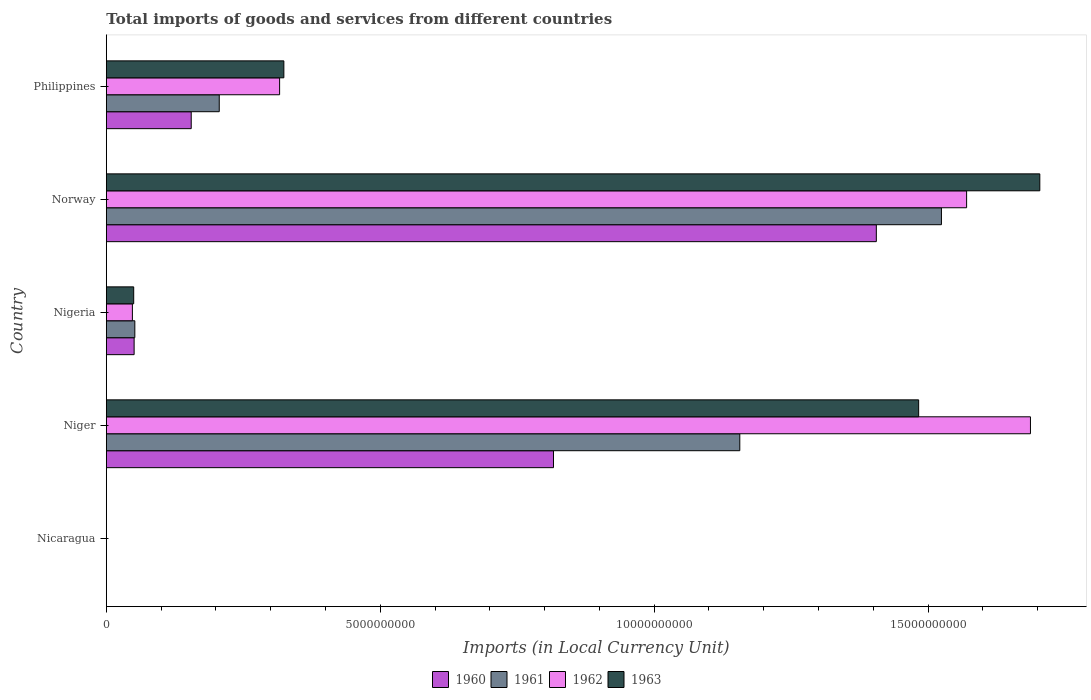How many different coloured bars are there?
Ensure brevity in your answer.  4. How many groups of bars are there?
Your answer should be very brief. 5. Are the number of bars per tick equal to the number of legend labels?
Offer a very short reply. Yes. How many bars are there on the 5th tick from the bottom?
Make the answer very short. 4. What is the label of the 5th group of bars from the top?
Keep it short and to the point. Nicaragua. In how many cases, is the number of bars for a given country not equal to the number of legend labels?
Offer a terse response. 0. What is the Amount of goods and services imports in 1963 in Nigeria?
Offer a terse response. 4.99e+08. Across all countries, what is the maximum Amount of goods and services imports in 1962?
Keep it short and to the point. 1.69e+1. Across all countries, what is the minimum Amount of goods and services imports in 1962?
Your answer should be very brief. 0.16. In which country was the Amount of goods and services imports in 1963 maximum?
Your response must be concise. Norway. In which country was the Amount of goods and services imports in 1960 minimum?
Give a very brief answer. Nicaragua. What is the total Amount of goods and services imports in 1960 in the graph?
Your answer should be compact. 2.43e+1. What is the difference between the Amount of goods and services imports in 1960 in Niger and that in Nigeria?
Ensure brevity in your answer.  7.66e+09. What is the difference between the Amount of goods and services imports in 1963 in Philippines and the Amount of goods and services imports in 1961 in Norway?
Offer a terse response. -1.20e+1. What is the average Amount of goods and services imports in 1960 per country?
Your answer should be compact. 4.85e+09. What is the difference between the Amount of goods and services imports in 1962 and Amount of goods and services imports in 1963 in Nicaragua?
Keep it short and to the point. -0.03. In how many countries, is the Amount of goods and services imports in 1963 greater than 8000000000 LCU?
Your answer should be very brief. 2. What is the ratio of the Amount of goods and services imports in 1962 in Nicaragua to that in Niger?
Provide a short and direct response. 9.54576297213908e-12. What is the difference between the highest and the second highest Amount of goods and services imports in 1963?
Keep it short and to the point. 2.21e+09. What is the difference between the highest and the lowest Amount of goods and services imports in 1963?
Keep it short and to the point. 1.70e+1. In how many countries, is the Amount of goods and services imports in 1963 greater than the average Amount of goods and services imports in 1963 taken over all countries?
Make the answer very short. 2. What does the 2nd bar from the bottom in Niger represents?
Provide a short and direct response. 1961. Are all the bars in the graph horizontal?
Keep it short and to the point. Yes. What is the difference between two consecutive major ticks on the X-axis?
Make the answer very short. 5.00e+09. Are the values on the major ticks of X-axis written in scientific E-notation?
Your answer should be compact. No. Does the graph contain any zero values?
Your response must be concise. No. Where does the legend appear in the graph?
Provide a short and direct response. Bottom center. How many legend labels are there?
Offer a very short reply. 4. How are the legend labels stacked?
Provide a short and direct response. Horizontal. What is the title of the graph?
Provide a short and direct response. Total imports of goods and services from different countries. What is the label or title of the X-axis?
Provide a short and direct response. Imports (in Local Currency Unit). What is the Imports (in Local Currency Unit) of 1960 in Nicaragua?
Offer a terse response. 0.12. What is the Imports (in Local Currency Unit) in 1961 in Nicaragua?
Give a very brief answer. 0.12. What is the Imports (in Local Currency Unit) of 1962 in Nicaragua?
Offer a very short reply. 0.16. What is the Imports (in Local Currency Unit) in 1963 in Nicaragua?
Give a very brief answer. 0.19. What is the Imports (in Local Currency Unit) of 1960 in Niger?
Your answer should be compact. 8.16e+09. What is the Imports (in Local Currency Unit) in 1961 in Niger?
Provide a succinct answer. 1.16e+1. What is the Imports (in Local Currency Unit) of 1962 in Niger?
Provide a succinct answer. 1.69e+1. What is the Imports (in Local Currency Unit) in 1963 in Niger?
Offer a terse response. 1.48e+1. What is the Imports (in Local Currency Unit) of 1960 in Nigeria?
Ensure brevity in your answer.  5.07e+08. What is the Imports (in Local Currency Unit) of 1961 in Nigeria?
Ensure brevity in your answer.  5.20e+08. What is the Imports (in Local Currency Unit) in 1962 in Nigeria?
Offer a very short reply. 4.76e+08. What is the Imports (in Local Currency Unit) of 1963 in Nigeria?
Provide a succinct answer. 4.99e+08. What is the Imports (in Local Currency Unit) of 1960 in Norway?
Offer a very short reply. 1.41e+1. What is the Imports (in Local Currency Unit) of 1961 in Norway?
Keep it short and to the point. 1.52e+1. What is the Imports (in Local Currency Unit) in 1962 in Norway?
Keep it short and to the point. 1.57e+1. What is the Imports (in Local Currency Unit) in 1963 in Norway?
Provide a succinct answer. 1.70e+1. What is the Imports (in Local Currency Unit) of 1960 in Philippines?
Ensure brevity in your answer.  1.55e+09. What is the Imports (in Local Currency Unit) in 1961 in Philippines?
Ensure brevity in your answer.  2.06e+09. What is the Imports (in Local Currency Unit) in 1962 in Philippines?
Give a very brief answer. 3.16e+09. What is the Imports (in Local Currency Unit) in 1963 in Philippines?
Provide a short and direct response. 3.24e+09. Across all countries, what is the maximum Imports (in Local Currency Unit) of 1960?
Your answer should be compact. 1.41e+1. Across all countries, what is the maximum Imports (in Local Currency Unit) of 1961?
Your answer should be compact. 1.52e+1. Across all countries, what is the maximum Imports (in Local Currency Unit) of 1962?
Give a very brief answer. 1.69e+1. Across all countries, what is the maximum Imports (in Local Currency Unit) in 1963?
Offer a terse response. 1.70e+1. Across all countries, what is the minimum Imports (in Local Currency Unit) in 1960?
Ensure brevity in your answer.  0.12. Across all countries, what is the minimum Imports (in Local Currency Unit) of 1961?
Offer a terse response. 0.12. Across all countries, what is the minimum Imports (in Local Currency Unit) of 1962?
Your answer should be very brief. 0.16. Across all countries, what is the minimum Imports (in Local Currency Unit) in 1963?
Your answer should be very brief. 0.19. What is the total Imports (in Local Currency Unit) of 1960 in the graph?
Offer a very short reply. 2.43e+1. What is the total Imports (in Local Currency Unit) in 1961 in the graph?
Your answer should be compact. 2.94e+1. What is the total Imports (in Local Currency Unit) of 1962 in the graph?
Offer a very short reply. 3.62e+1. What is the total Imports (in Local Currency Unit) of 1963 in the graph?
Offer a very short reply. 3.56e+1. What is the difference between the Imports (in Local Currency Unit) of 1960 in Nicaragua and that in Niger?
Offer a very short reply. -8.16e+09. What is the difference between the Imports (in Local Currency Unit) of 1961 in Nicaragua and that in Niger?
Your answer should be very brief. -1.16e+1. What is the difference between the Imports (in Local Currency Unit) of 1962 in Nicaragua and that in Niger?
Your answer should be compact. -1.69e+1. What is the difference between the Imports (in Local Currency Unit) in 1963 in Nicaragua and that in Niger?
Ensure brevity in your answer.  -1.48e+1. What is the difference between the Imports (in Local Currency Unit) in 1960 in Nicaragua and that in Nigeria?
Offer a terse response. -5.07e+08. What is the difference between the Imports (in Local Currency Unit) of 1961 in Nicaragua and that in Nigeria?
Your answer should be very brief. -5.20e+08. What is the difference between the Imports (in Local Currency Unit) of 1962 in Nicaragua and that in Nigeria?
Give a very brief answer. -4.76e+08. What is the difference between the Imports (in Local Currency Unit) in 1963 in Nicaragua and that in Nigeria?
Your answer should be compact. -4.99e+08. What is the difference between the Imports (in Local Currency Unit) of 1960 in Nicaragua and that in Norway?
Your response must be concise. -1.41e+1. What is the difference between the Imports (in Local Currency Unit) in 1961 in Nicaragua and that in Norway?
Your response must be concise. -1.52e+1. What is the difference between the Imports (in Local Currency Unit) of 1962 in Nicaragua and that in Norway?
Your answer should be very brief. -1.57e+1. What is the difference between the Imports (in Local Currency Unit) of 1963 in Nicaragua and that in Norway?
Keep it short and to the point. -1.70e+1. What is the difference between the Imports (in Local Currency Unit) of 1960 in Nicaragua and that in Philippines?
Your answer should be compact. -1.55e+09. What is the difference between the Imports (in Local Currency Unit) in 1961 in Nicaragua and that in Philippines?
Give a very brief answer. -2.06e+09. What is the difference between the Imports (in Local Currency Unit) of 1962 in Nicaragua and that in Philippines?
Provide a short and direct response. -3.16e+09. What is the difference between the Imports (in Local Currency Unit) in 1963 in Nicaragua and that in Philippines?
Keep it short and to the point. -3.24e+09. What is the difference between the Imports (in Local Currency Unit) of 1960 in Niger and that in Nigeria?
Give a very brief answer. 7.66e+09. What is the difference between the Imports (in Local Currency Unit) of 1961 in Niger and that in Nigeria?
Provide a short and direct response. 1.10e+1. What is the difference between the Imports (in Local Currency Unit) in 1962 in Niger and that in Nigeria?
Offer a very short reply. 1.64e+1. What is the difference between the Imports (in Local Currency Unit) in 1963 in Niger and that in Nigeria?
Ensure brevity in your answer.  1.43e+1. What is the difference between the Imports (in Local Currency Unit) of 1960 in Niger and that in Norway?
Offer a terse response. -5.89e+09. What is the difference between the Imports (in Local Currency Unit) in 1961 in Niger and that in Norway?
Ensure brevity in your answer.  -3.68e+09. What is the difference between the Imports (in Local Currency Unit) in 1962 in Niger and that in Norway?
Offer a terse response. 1.17e+09. What is the difference between the Imports (in Local Currency Unit) in 1963 in Niger and that in Norway?
Offer a very short reply. -2.21e+09. What is the difference between the Imports (in Local Currency Unit) in 1960 in Niger and that in Philippines?
Ensure brevity in your answer.  6.61e+09. What is the difference between the Imports (in Local Currency Unit) of 1961 in Niger and that in Philippines?
Provide a short and direct response. 9.50e+09. What is the difference between the Imports (in Local Currency Unit) of 1962 in Niger and that in Philippines?
Offer a very short reply. 1.37e+1. What is the difference between the Imports (in Local Currency Unit) in 1963 in Niger and that in Philippines?
Keep it short and to the point. 1.16e+1. What is the difference between the Imports (in Local Currency Unit) in 1960 in Nigeria and that in Norway?
Your answer should be very brief. -1.35e+1. What is the difference between the Imports (in Local Currency Unit) in 1961 in Nigeria and that in Norway?
Your answer should be very brief. -1.47e+1. What is the difference between the Imports (in Local Currency Unit) in 1962 in Nigeria and that in Norway?
Your answer should be compact. -1.52e+1. What is the difference between the Imports (in Local Currency Unit) in 1963 in Nigeria and that in Norway?
Provide a short and direct response. -1.65e+1. What is the difference between the Imports (in Local Currency Unit) of 1960 in Nigeria and that in Philippines?
Provide a short and direct response. -1.04e+09. What is the difference between the Imports (in Local Currency Unit) of 1961 in Nigeria and that in Philippines?
Your answer should be compact. -1.54e+09. What is the difference between the Imports (in Local Currency Unit) in 1962 in Nigeria and that in Philippines?
Give a very brief answer. -2.69e+09. What is the difference between the Imports (in Local Currency Unit) of 1963 in Nigeria and that in Philippines?
Your response must be concise. -2.74e+09. What is the difference between the Imports (in Local Currency Unit) in 1960 in Norway and that in Philippines?
Your answer should be compact. 1.25e+1. What is the difference between the Imports (in Local Currency Unit) of 1961 in Norway and that in Philippines?
Offer a terse response. 1.32e+1. What is the difference between the Imports (in Local Currency Unit) in 1962 in Norway and that in Philippines?
Give a very brief answer. 1.25e+1. What is the difference between the Imports (in Local Currency Unit) of 1963 in Norway and that in Philippines?
Provide a short and direct response. 1.38e+1. What is the difference between the Imports (in Local Currency Unit) in 1960 in Nicaragua and the Imports (in Local Currency Unit) in 1961 in Niger?
Give a very brief answer. -1.16e+1. What is the difference between the Imports (in Local Currency Unit) of 1960 in Nicaragua and the Imports (in Local Currency Unit) of 1962 in Niger?
Make the answer very short. -1.69e+1. What is the difference between the Imports (in Local Currency Unit) of 1960 in Nicaragua and the Imports (in Local Currency Unit) of 1963 in Niger?
Your response must be concise. -1.48e+1. What is the difference between the Imports (in Local Currency Unit) of 1961 in Nicaragua and the Imports (in Local Currency Unit) of 1962 in Niger?
Make the answer very short. -1.69e+1. What is the difference between the Imports (in Local Currency Unit) of 1961 in Nicaragua and the Imports (in Local Currency Unit) of 1963 in Niger?
Give a very brief answer. -1.48e+1. What is the difference between the Imports (in Local Currency Unit) in 1962 in Nicaragua and the Imports (in Local Currency Unit) in 1963 in Niger?
Make the answer very short. -1.48e+1. What is the difference between the Imports (in Local Currency Unit) of 1960 in Nicaragua and the Imports (in Local Currency Unit) of 1961 in Nigeria?
Ensure brevity in your answer.  -5.20e+08. What is the difference between the Imports (in Local Currency Unit) of 1960 in Nicaragua and the Imports (in Local Currency Unit) of 1962 in Nigeria?
Ensure brevity in your answer.  -4.76e+08. What is the difference between the Imports (in Local Currency Unit) in 1960 in Nicaragua and the Imports (in Local Currency Unit) in 1963 in Nigeria?
Your answer should be compact. -4.99e+08. What is the difference between the Imports (in Local Currency Unit) in 1961 in Nicaragua and the Imports (in Local Currency Unit) in 1962 in Nigeria?
Offer a terse response. -4.76e+08. What is the difference between the Imports (in Local Currency Unit) of 1961 in Nicaragua and the Imports (in Local Currency Unit) of 1963 in Nigeria?
Your answer should be very brief. -4.99e+08. What is the difference between the Imports (in Local Currency Unit) in 1962 in Nicaragua and the Imports (in Local Currency Unit) in 1963 in Nigeria?
Offer a very short reply. -4.99e+08. What is the difference between the Imports (in Local Currency Unit) in 1960 in Nicaragua and the Imports (in Local Currency Unit) in 1961 in Norway?
Ensure brevity in your answer.  -1.52e+1. What is the difference between the Imports (in Local Currency Unit) of 1960 in Nicaragua and the Imports (in Local Currency Unit) of 1962 in Norway?
Ensure brevity in your answer.  -1.57e+1. What is the difference between the Imports (in Local Currency Unit) in 1960 in Nicaragua and the Imports (in Local Currency Unit) in 1963 in Norway?
Give a very brief answer. -1.70e+1. What is the difference between the Imports (in Local Currency Unit) in 1961 in Nicaragua and the Imports (in Local Currency Unit) in 1962 in Norway?
Ensure brevity in your answer.  -1.57e+1. What is the difference between the Imports (in Local Currency Unit) of 1961 in Nicaragua and the Imports (in Local Currency Unit) of 1963 in Norway?
Give a very brief answer. -1.70e+1. What is the difference between the Imports (in Local Currency Unit) in 1962 in Nicaragua and the Imports (in Local Currency Unit) in 1963 in Norway?
Give a very brief answer. -1.70e+1. What is the difference between the Imports (in Local Currency Unit) of 1960 in Nicaragua and the Imports (in Local Currency Unit) of 1961 in Philippines?
Your answer should be very brief. -2.06e+09. What is the difference between the Imports (in Local Currency Unit) in 1960 in Nicaragua and the Imports (in Local Currency Unit) in 1962 in Philippines?
Your answer should be very brief. -3.16e+09. What is the difference between the Imports (in Local Currency Unit) of 1960 in Nicaragua and the Imports (in Local Currency Unit) of 1963 in Philippines?
Provide a short and direct response. -3.24e+09. What is the difference between the Imports (in Local Currency Unit) in 1961 in Nicaragua and the Imports (in Local Currency Unit) in 1962 in Philippines?
Ensure brevity in your answer.  -3.16e+09. What is the difference between the Imports (in Local Currency Unit) in 1961 in Nicaragua and the Imports (in Local Currency Unit) in 1963 in Philippines?
Your answer should be very brief. -3.24e+09. What is the difference between the Imports (in Local Currency Unit) of 1962 in Nicaragua and the Imports (in Local Currency Unit) of 1963 in Philippines?
Your answer should be very brief. -3.24e+09. What is the difference between the Imports (in Local Currency Unit) in 1960 in Niger and the Imports (in Local Currency Unit) in 1961 in Nigeria?
Provide a succinct answer. 7.64e+09. What is the difference between the Imports (in Local Currency Unit) in 1960 in Niger and the Imports (in Local Currency Unit) in 1962 in Nigeria?
Provide a short and direct response. 7.69e+09. What is the difference between the Imports (in Local Currency Unit) of 1960 in Niger and the Imports (in Local Currency Unit) of 1963 in Nigeria?
Your response must be concise. 7.66e+09. What is the difference between the Imports (in Local Currency Unit) of 1961 in Niger and the Imports (in Local Currency Unit) of 1962 in Nigeria?
Ensure brevity in your answer.  1.11e+1. What is the difference between the Imports (in Local Currency Unit) of 1961 in Niger and the Imports (in Local Currency Unit) of 1963 in Nigeria?
Keep it short and to the point. 1.11e+1. What is the difference between the Imports (in Local Currency Unit) of 1962 in Niger and the Imports (in Local Currency Unit) of 1963 in Nigeria?
Make the answer very short. 1.64e+1. What is the difference between the Imports (in Local Currency Unit) of 1960 in Niger and the Imports (in Local Currency Unit) of 1961 in Norway?
Make the answer very short. -7.08e+09. What is the difference between the Imports (in Local Currency Unit) in 1960 in Niger and the Imports (in Local Currency Unit) in 1962 in Norway?
Ensure brevity in your answer.  -7.54e+09. What is the difference between the Imports (in Local Currency Unit) in 1960 in Niger and the Imports (in Local Currency Unit) in 1963 in Norway?
Offer a very short reply. -8.88e+09. What is the difference between the Imports (in Local Currency Unit) in 1961 in Niger and the Imports (in Local Currency Unit) in 1962 in Norway?
Make the answer very short. -4.14e+09. What is the difference between the Imports (in Local Currency Unit) of 1961 in Niger and the Imports (in Local Currency Unit) of 1963 in Norway?
Keep it short and to the point. -5.48e+09. What is the difference between the Imports (in Local Currency Unit) in 1962 in Niger and the Imports (in Local Currency Unit) in 1963 in Norway?
Provide a short and direct response. -1.71e+08. What is the difference between the Imports (in Local Currency Unit) of 1960 in Niger and the Imports (in Local Currency Unit) of 1961 in Philippines?
Ensure brevity in your answer.  6.10e+09. What is the difference between the Imports (in Local Currency Unit) in 1960 in Niger and the Imports (in Local Currency Unit) in 1962 in Philippines?
Offer a very short reply. 5.00e+09. What is the difference between the Imports (in Local Currency Unit) in 1960 in Niger and the Imports (in Local Currency Unit) in 1963 in Philippines?
Provide a succinct answer. 4.92e+09. What is the difference between the Imports (in Local Currency Unit) of 1961 in Niger and the Imports (in Local Currency Unit) of 1962 in Philippines?
Offer a terse response. 8.40e+09. What is the difference between the Imports (in Local Currency Unit) in 1961 in Niger and the Imports (in Local Currency Unit) in 1963 in Philippines?
Your answer should be very brief. 8.32e+09. What is the difference between the Imports (in Local Currency Unit) of 1962 in Niger and the Imports (in Local Currency Unit) of 1963 in Philippines?
Offer a terse response. 1.36e+1. What is the difference between the Imports (in Local Currency Unit) in 1960 in Nigeria and the Imports (in Local Currency Unit) in 1961 in Norway?
Offer a very short reply. -1.47e+1. What is the difference between the Imports (in Local Currency Unit) in 1960 in Nigeria and the Imports (in Local Currency Unit) in 1962 in Norway?
Provide a succinct answer. -1.52e+1. What is the difference between the Imports (in Local Currency Unit) in 1960 in Nigeria and the Imports (in Local Currency Unit) in 1963 in Norway?
Your response must be concise. -1.65e+1. What is the difference between the Imports (in Local Currency Unit) of 1961 in Nigeria and the Imports (in Local Currency Unit) of 1962 in Norway?
Your response must be concise. -1.52e+1. What is the difference between the Imports (in Local Currency Unit) in 1961 in Nigeria and the Imports (in Local Currency Unit) in 1963 in Norway?
Give a very brief answer. -1.65e+1. What is the difference between the Imports (in Local Currency Unit) of 1962 in Nigeria and the Imports (in Local Currency Unit) of 1963 in Norway?
Your answer should be very brief. -1.66e+1. What is the difference between the Imports (in Local Currency Unit) in 1960 in Nigeria and the Imports (in Local Currency Unit) in 1961 in Philippines?
Provide a succinct answer. -1.55e+09. What is the difference between the Imports (in Local Currency Unit) of 1960 in Nigeria and the Imports (in Local Currency Unit) of 1962 in Philippines?
Offer a terse response. -2.66e+09. What is the difference between the Imports (in Local Currency Unit) of 1960 in Nigeria and the Imports (in Local Currency Unit) of 1963 in Philippines?
Provide a succinct answer. -2.73e+09. What is the difference between the Imports (in Local Currency Unit) in 1961 in Nigeria and the Imports (in Local Currency Unit) in 1962 in Philippines?
Ensure brevity in your answer.  -2.64e+09. What is the difference between the Imports (in Local Currency Unit) of 1961 in Nigeria and the Imports (in Local Currency Unit) of 1963 in Philippines?
Keep it short and to the point. -2.72e+09. What is the difference between the Imports (in Local Currency Unit) of 1962 in Nigeria and the Imports (in Local Currency Unit) of 1963 in Philippines?
Provide a short and direct response. -2.76e+09. What is the difference between the Imports (in Local Currency Unit) of 1960 in Norway and the Imports (in Local Currency Unit) of 1961 in Philippines?
Offer a terse response. 1.20e+1. What is the difference between the Imports (in Local Currency Unit) in 1960 in Norway and the Imports (in Local Currency Unit) in 1962 in Philippines?
Your answer should be compact. 1.09e+1. What is the difference between the Imports (in Local Currency Unit) of 1960 in Norway and the Imports (in Local Currency Unit) of 1963 in Philippines?
Your response must be concise. 1.08e+1. What is the difference between the Imports (in Local Currency Unit) of 1961 in Norway and the Imports (in Local Currency Unit) of 1962 in Philippines?
Offer a very short reply. 1.21e+1. What is the difference between the Imports (in Local Currency Unit) in 1961 in Norway and the Imports (in Local Currency Unit) in 1963 in Philippines?
Your answer should be compact. 1.20e+1. What is the difference between the Imports (in Local Currency Unit) of 1962 in Norway and the Imports (in Local Currency Unit) of 1963 in Philippines?
Ensure brevity in your answer.  1.25e+1. What is the average Imports (in Local Currency Unit) in 1960 per country?
Your response must be concise. 4.85e+09. What is the average Imports (in Local Currency Unit) in 1961 per country?
Provide a succinct answer. 5.88e+09. What is the average Imports (in Local Currency Unit) in 1962 per country?
Offer a very short reply. 7.24e+09. What is the average Imports (in Local Currency Unit) of 1963 per country?
Offer a very short reply. 7.12e+09. What is the difference between the Imports (in Local Currency Unit) in 1960 and Imports (in Local Currency Unit) in 1961 in Nicaragua?
Keep it short and to the point. -0. What is the difference between the Imports (in Local Currency Unit) in 1960 and Imports (in Local Currency Unit) in 1962 in Nicaragua?
Provide a succinct answer. -0.04. What is the difference between the Imports (in Local Currency Unit) in 1960 and Imports (in Local Currency Unit) in 1963 in Nicaragua?
Your response must be concise. -0.06. What is the difference between the Imports (in Local Currency Unit) of 1961 and Imports (in Local Currency Unit) of 1962 in Nicaragua?
Your answer should be compact. -0.04. What is the difference between the Imports (in Local Currency Unit) in 1961 and Imports (in Local Currency Unit) in 1963 in Nicaragua?
Offer a terse response. -0.06. What is the difference between the Imports (in Local Currency Unit) in 1962 and Imports (in Local Currency Unit) in 1963 in Nicaragua?
Your response must be concise. -0.03. What is the difference between the Imports (in Local Currency Unit) in 1960 and Imports (in Local Currency Unit) in 1961 in Niger?
Provide a succinct answer. -3.40e+09. What is the difference between the Imports (in Local Currency Unit) in 1960 and Imports (in Local Currency Unit) in 1962 in Niger?
Provide a short and direct response. -8.71e+09. What is the difference between the Imports (in Local Currency Unit) in 1960 and Imports (in Local Currency Unit) in 1963 in Niger?
Make the answer very short. -6.67e+09. What is the difference between the Imports (in Local Currency Unit) in 1961 and Imports (in Local Currency Unit) in 1962 in Niger?
Make the answer very short. -5.31e+09. What is the difference between the Imports (in Local Currency Unit) in 1961 and Imports (in Local Currency Unit) in 1963 in Niger?
Give a very brief answer. -3.26e+09. What is the difference between the Imports (in Local Currency Unit) of 1962 and Imports (in Local Currency Unit) of 1963 in Niger?
Your answer should be compact. 2.04e+09. What is the difference between the Imports (in Local Currency Unit) in 1960 and Imports (in Local Currency Unit) in 1961 in Nigeria?
Provide a short and direct response. -1.28e+07. What is the difference between the Imports (in Local Currency Unit) in 1960 and Imports (in Local Currency Unit) in 1962 in Nigeria?
Provide a succinct answer. 3.18e+07. What is the difference between the Imports (in Local Currency Unit) in 1960 and Imports (in Local Currency Unit) in 1963 in Nigeria?
Your answer should be compact. 7.80e+06. What is the difference between the Imports (in Local Currency Unit) of 1961 and Imports (in Local Currency Unit) of 1962 in Nigeria?
Make the answer very short. 4.46e+07. What is the difference between the Imports (in Local Currency Unit) of 1961 and Imports (in Local Currency Unit) of 1963 in Nigeria?
Your response must be concise. 2.06e+07. What is the difference between the Imports (in Local Currency Unit) of 1962 and Imports (in Local Currency Unit) of 1963 in Nigeria?
Provide a short and direct response. -2.40e+07. What is the difference between the Imports (in Local Currency Unit) of 1960 and Imports (in Local Currency Unit) of 1961 in Norway?
Offer a very short reply. -1.19e+09. What is the difference between the Imports (in Local Currency Unit) in 1960 and Imports (in Local Currency Unit) in 1962 in Norway?
Your response must be concise. -1.65e+09. What is the difference between the Imports (in Local Currency Unit) in 1960 and Imports (in Local Currency Unit) in 1963 in Norway?
Your answer should be very brief. -2.98e+09. What is the difference between the Imports (in Local Currency Unit) of 1961 and Imports (in Local Currency Unit) of 1962 in Norway?
Provide a succinct answer. -4.60e+08. What is the difference between the Imports (in Local Currency Unit) in 1961 and Imports (in Local Currency Unit) in 1963 in Norway?
Your answer should be very brief. -1.80e+09. What is the difference between the Imports (in Local Currency Unit) of 1962 and Imports (in Local Currency Unit) of 1963 in Norway?
Your answer should be compact. -1.34e+09. What is the difference between the Imports (in Local Currency Unit) of 1960 and Imports (in Local Currency Unit) of 1961 in Philippines?
Offer a terse response. -5.12e+08. What is the difference between the Imports (in Local Currency Unit) in 1960 and Imports (in Local Currency Unit) in 1962 in Philippines?
Give a very brief answer. -1.61e+09. What is the difference between the Imports (in Local Currency Unit) in 1960 and Imports (in Local Currency Unit) in 1963 in Philippines?
Offer a terse response. -1.69e+09. What is the difference between the Imports (in Local Currency Unit) of 1961 and Imports (in Local Currency Unit) of 1962 in Philippines?
Give a very brief answer. -1.10e+09. What is the difference between the Imports (in Local Currency Unit) in 1961 and Imports (in Local Currency Unit) in 1963 in Philippines?
Your answer should be very brief. -1.18e+09. What is the difference between the Imports (in Local Currency Unit) in 1962 and Imports (in Local Currency Unit) in 1963 in Philippines?
Your answer should be very brief. -7.75e+07. What is the ratio of the Imports (in Local Currency Unit) of 1960 in Nicaragua to that in Niger?
Keep it short and to the point. 0. What is the ratio of the Imports (in Local Currency Unit) in 1961 in Nicaragua to that in Niger?
Offer a very short reply. 0. What is the ratio of the Imports (in Local Currency Unit) of 1962 in Nicaragua to that in Niger?
Provide a short and direct response. 0. What is the ratio of the Imports (in Local Currency Unit) in 1962 in Nicaragua to that in Nigeria?
Make the answer very short. 0. What is the ratio of the Imports (in Local Currency Unit) of 1960 in Nicaragua to that in Norway?
Your answer should be compact. 0. What is the ratio of the Imports (in Local Currency Unit) of 1961 in Nicaragua to that in Norway?
Your answer should be compact. 0. What is the ratio of the Imports (in Local Currency Unit) of 1962 in Nicaragua to that in Norway?
Offer a very short reply. 0. What is the ratio of the Imports (in Local Currency Unit) of 1960 in Nicaragua to that in Philippines?
Provide a succinct answer. 0. What is the ratio of the Imports (in Local Currency Unit) in 1960 in Niger to that in Nigeria?
Make the answer very short. 16.09. What is the ratio of the Imports (in Local Currency Unit) in 1961 in Niger to that in Nigeria?
Offer a terse response. 22.23. What is the ratio of the Imports (in Local Currency Unit) of 1962 in Niger to that in Nigeria?
Keep it short and to the point. 35.47. What is the ratio of the Imports (in Local Currency Unit) of 1963 in Niger to that in Nigeria?
Offer a terse response. 29.69. What is the ratio of the Imports (in Local Currency Unit) of 1960 in Niger to that in Norway?
Provide a succinct answer. 0.58. What is the ratio of the Imports (in Local Currency Unit) in 1961 in Niger to that in Norway?
Give a very brief answer. 0.76. What is the ratio of the Imports (in Local Currency Unit) of 1962 in Niger to that in Norway?
Your answer should be compact. 1.07. What is the ratio of the Imports (in Local Currency Unit) in 1963 in Niger to that in Norway?
Ensure brevity in your answer.  0.87. What is the ratio of the Imports (in Local Currency Unit) in 1960 in Niger to that in Philippines?
Provide a short and direct response. 5.27. What is the ratio of the Imports (in Local Currency Unit) in 1961 in Niger to that in Philippines?
Offer a very short reply. 5.61. What is the ratio of the Imports (in Local Currency Unit) in 1962 in Niger to that in Philippines?
Your answer should be very brief. 5.33. What is the ratio of the Imports (in Local Currency Unit) of 1963 in Niger to that in Philippines?
Your answer should be very brief. 4.58. What is the ratio of the Imports (in Local Currency Unit) of 1960 in Nigeria to that in Norway?
Give a very brief answer. 0.04. What is the ratio of the Imports (in Local Currency Unit) of 1961 in Nigeria to that in Norway?
Offer a very short reply. 0.03. What is the ratio of the Imports (in Local Currency Unit) in 1962 in Nigeria to that in Norway?
Give a very brief answer. 0.03. What is the ratio of the Imports (in Local Currency Unit) in 1963 in Nigeria to that in Norway?
Your response must be concise. 0.03. What is the ratio of the Imports (in Local Currency Unit) in 1960 in Nigeria to that in Philippines?
Give a very brief answer. 0.33. What is the ratio of the Imports (in Local Currency Unit) in 1961 in Nigeria to that in Philippines?
Your answer should be very brief. 0.25. What is the ratio of the Imports (in Local Currency Unit) in 1962 in Nigeria to that in Philippines?
Provide a short and direct response. 0.15. What is the ratio of the Imports (in Local Currency Unit) of 1963 in Nigeria to that in Philippines?
Your response must be concise. 0.15. What is the ratio of the Imports (in Local Currency Unit) in 1960 in Norway to that in Philippines?
Keep it short and to the point. 9.07. What is the ratio of the Imports (in Local Currency Unit) in 1961 in Norway to that in Philippines?
Provide a succinct answer. 7.4. What is the ratio of the Imports (in Local Currency Unit) of 1962 in Norway to that in Philippines?
Offer a terse response. 4.96. What is the ratio of the Imports (in Local Currency Unit) in 1963 in Norway to that in Philippines?
Ensure brevity in your answer.  5.26. What is the difference between the highest and the second highest Imports (in Local Currency Unit) in 1960?
Give a very brief answer. 5.89e+09. What is the difference between the highest and the second highest Imports (in Local Currency Unit) in 1961?
Offer a very short reply. 3.68e+09. What is the difference between the highest and the second highest Imports (in Local Currency Unit) in 1962?
Ensure brevity in your answer.  1.17e+09. What is the difference between the highest and the second highest Imports (in Local Currency Unit) of 1963?
Ensure brevity in your answer.  2.21e+09. What is the difference between the highest and the lowest Imports (in Local Currency Unit) in 1960?
Ensure brevity in your answer.  1.41e+1. What is the difference between the highest and the lowest Imports (in Local Currency Unit) in 1961?
Provide a short and direct response. 1.52e+1. What is the difference between the highest and the lowest Imports (in Local Currency Unit) of 1962?
Your answer should be compact. 1.69e+1. What is the difference between the highest and the lowest Imports (in Local Currency Unit) in 1963?
Provide a short and direct response. 1.70e+1. 